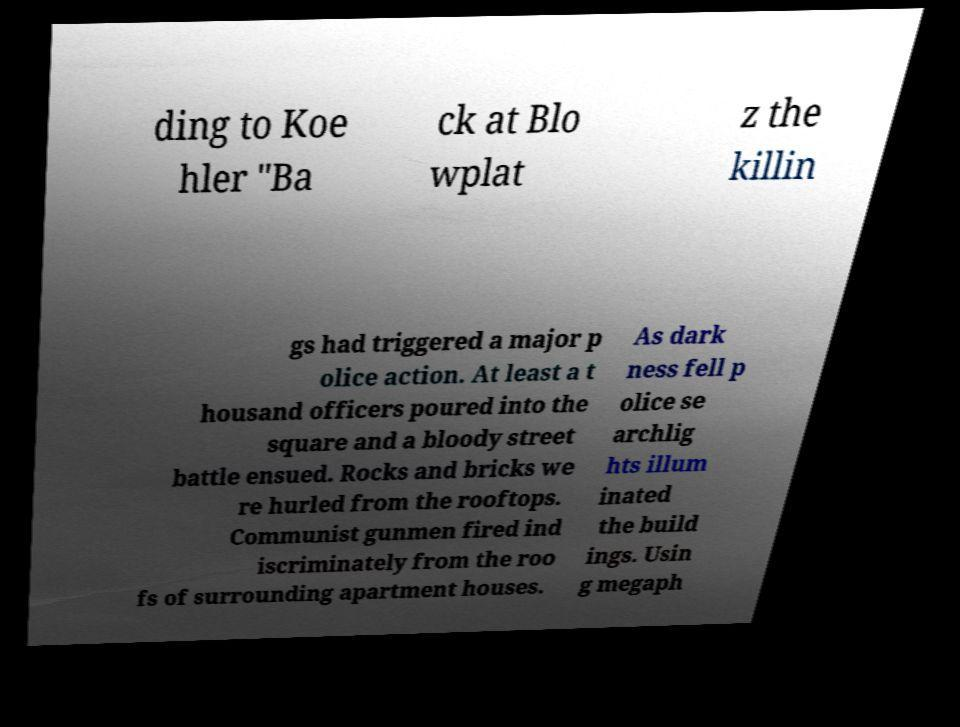Please read and relay the text visible in this image. What does it say? ding to Koe hler "Ba ck at Blo wplat z the killin gs had triggered a major p olice action. At least a t housand officers poured into the square and a bloody street battle ensued. Rocks and bricks we re hurled from the rooftops. Communist gunmen fired ind iscriminately from the roo fs of surrounding apartment houses. As dark ness fell p olice se archlig hts illum inated the build ings. Usin g megaph 